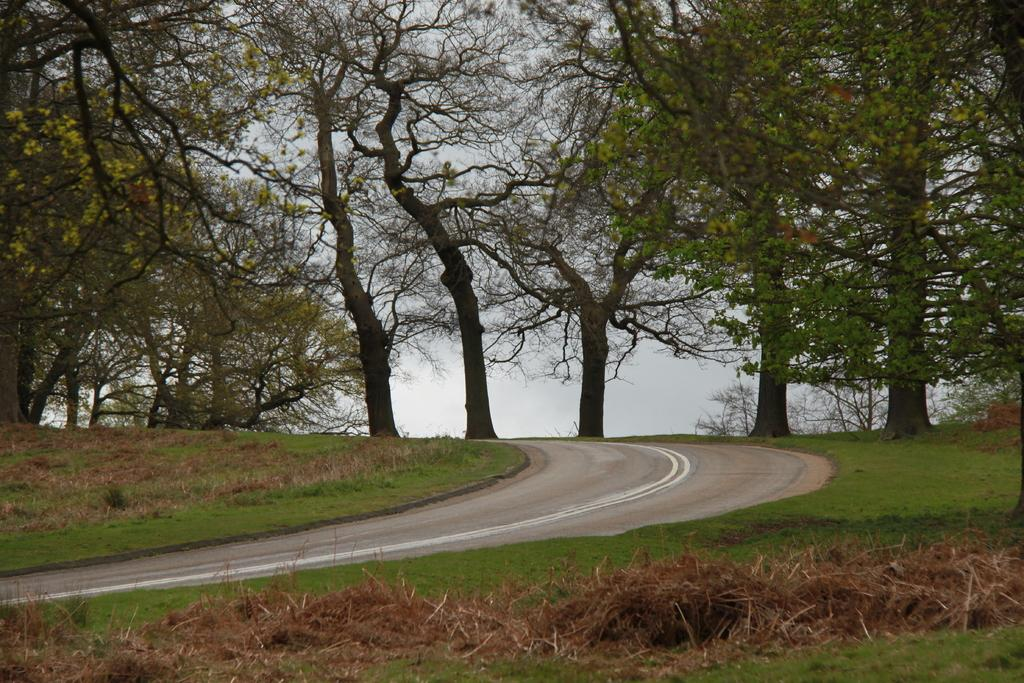What is the main subject of the image? The main subject of the image is a road. What can be seen alongside the road in the image? There are trees in the image. What is visible at the top of the image? The sky is visible at the top of the image. Where is the road located in the image? The road is at the bottom of the image. What type of vegetation is present in the image? There is grass in the image. Can you tell me who the partner is in the image? There is no partner present in the image; it depicts a road, trees, sky, and grass. 